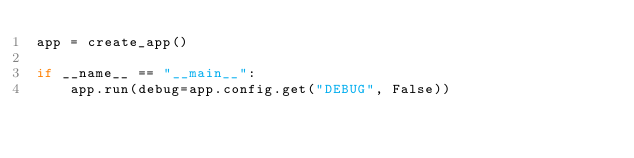<code> <loc_0><loc_0><loc_500><loc_500><_Python_>app = create_app()

if __name__ == "__main__":
    app.run(debug=app.config.get("DEBUG", False))
</code> 